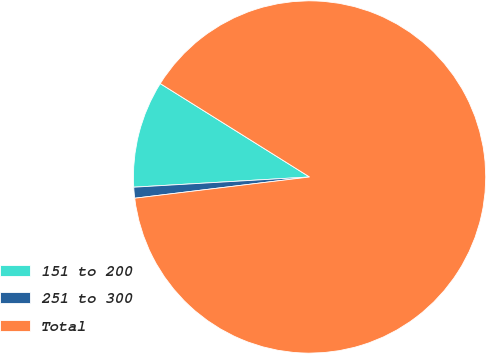Convert chart to OTSL. <chart><loc_0><loc_0><loc_500><loc_500><pie_chart><fcel>151 to 200<fcel>251 to 300<fcel>Total<nl><fcel>9.82%<fcel>1.0%<fcel>89.17%<nl></chart> 